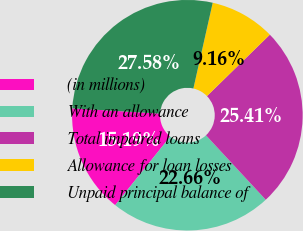<chart> <loc_0><loc_0><loc_500><loc_500><pie_chart><fcel>(in millions)<fcel>With an allowance<fcel>Total impaired loans<fcel>Allowance for loan losses<fcel>Unpaid principal balance of<nl><fcel>15.19%<fcel>22.66%<fcel>25.41%<fcel>9.16%<fcel>27.58%<nl></chart> 